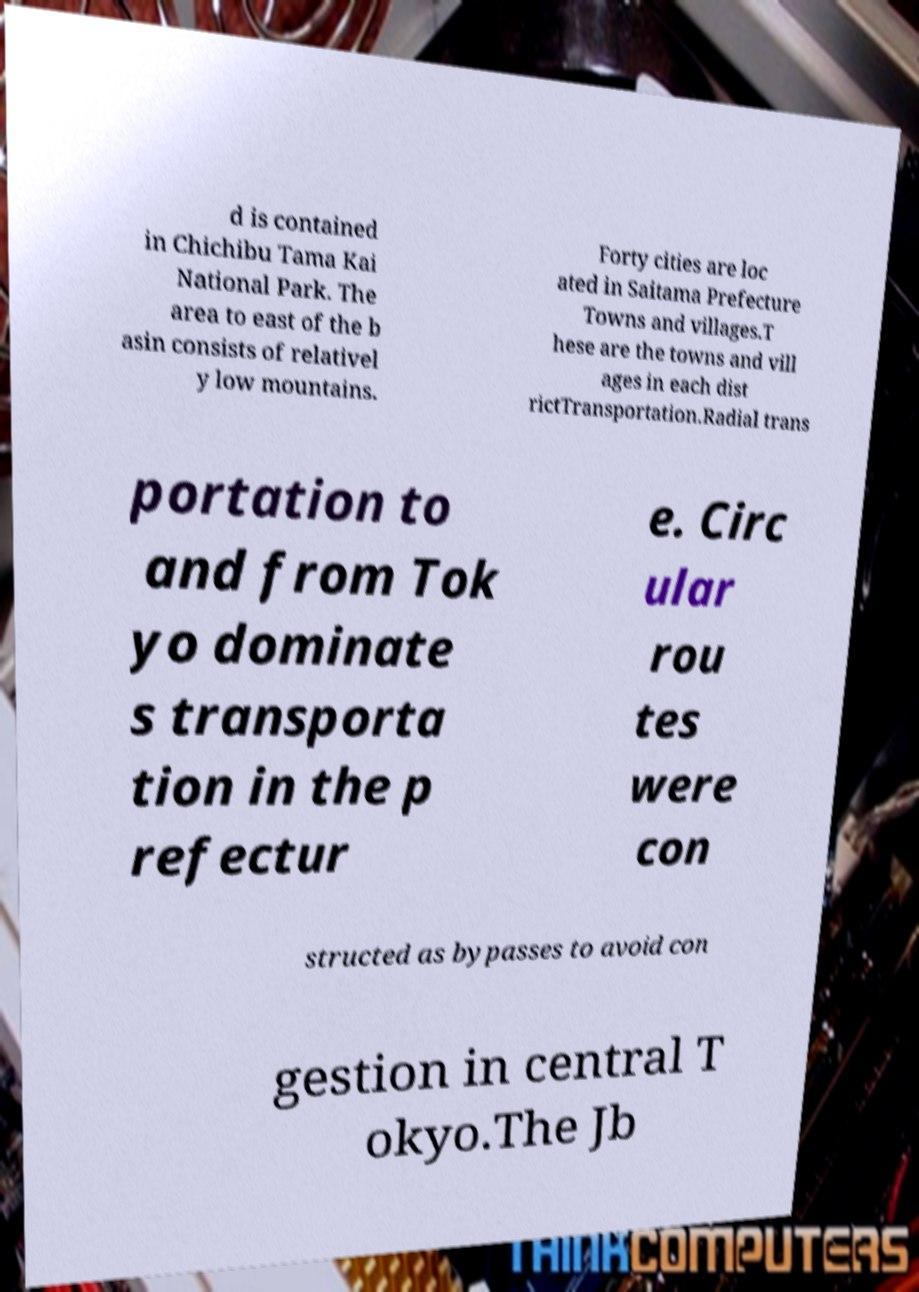I need the written content from this picture converted into text. Can you do that? d is contained in Chichibu Tama Kai National Park. The area to east of the b asin consists of relativel y low mountains. Forty cities are loc ated in Saitama Prefecture Towns and villages.T hese are the towns and vill ages in each dist rictTransportation.Radial trans portation to and from Tok yo dominate s transporta tion in the p refectur e. Circ ular rou tes were con structed as bypasses to avoid con gestion in central T okyo.The Jb 